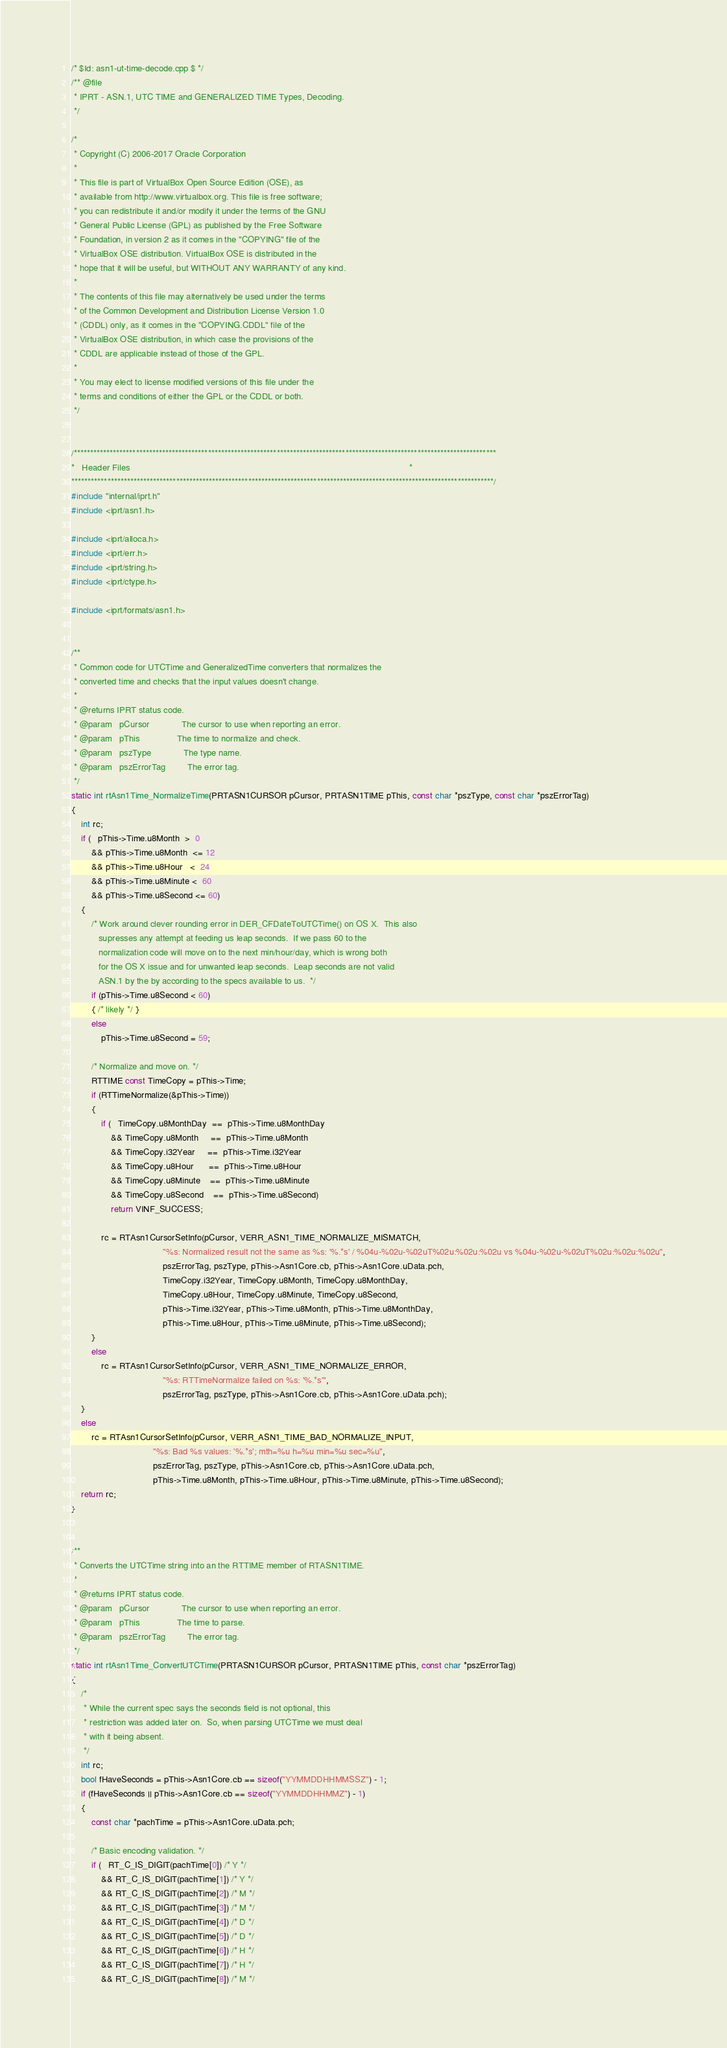Convert code to text. <code><loc_0><loc_0><loc_500><loc_500><_C++_>/* $Id: asn1-ut-time-decode.cpp $ */
/** @file
 * IPRT - ASN.1, UTC TIME and GENERALIZED TIME Types, Decoding.
 */

/*
 * Copyright (C) 2006-2017 Oracle Corporation
 *
 * This file is part of VirtualBox Open Source Edition (OSE), as
 * available from http://www.virtualbox.org. This file is free software;
 * you can redistribute it and/or modify it under the terms of the GNU
 * General Public License (GPL) as published by the Free Software
 * Foundation, in version 2 as it comes in the "COPYING" file of the
 * VirtualBox OSE distribution. VirtualBox OSE is distributed in the
 * hope that it will be useful, but WITHOUT ANY WARRANTY of any kind.
 *
 * The contents of this file may alternatively be used under the terms
 * of the Common Development and Distribution License Version 1.0
 * (CDDL) only, as it comes in the "COPYING.CDDL" file of the
 * VirtualBox OSE distribution, in which case the provisions of the
 * CDDL are applicable instead of those of the GPL.
 *
 * You may elect to license modified versions of this file under the
 * terms and conditions of either the GPL or the CDDL or both.
 */


/*********************************************************************************************************************************
*   Header Files                                                                                                                 *
*********************************************************************************************************************************/
#include "internal/iprt.h"
#include <iprt/asn1.h>

#include <iprt/alloca.h>
#include <iprt/err.h>
#include <iprt/string.h>
#include <iprt/ctype.h>

#include <iprt/formats/asn1.h>


/**
 * Common code for UTCTime and GeneralizedTime converters that normalizes the
 * converted time and checks that the input values doesn't change.
 *
 * @returns IPRT status code.
 * @param   pCursor             The cursor to use when reporting an error.
 * @param   pThis               The time to normalize and check.
 * @param   pszType             The type name.
 * @param   pszErrorTag         The error tag.
 */
static int rtAsn1Time_NormalizeTime(PRTASN1CURSOR pCursor, PRTASN1TIME pThis, const char *pszType, const char *pszErrorTag)
{
    int rc;
    if (   pThis->Time.u8Month  >  0
        && pThis->Time.u8Month  <= 12
        && pThis->Time.u8Hour   <  24
        && pThis->Time.u8Minute <  60
        && pThis->Time.u8Second <= 60)
    {
        /* Work around clever rounding error in DER_CFDateToUTCTime() on OS X.  This also
           supresses any attempt at feeding us leap seconds.  If we pass 60 to the
           normalization code will move on to the next min/hour/day, which is wrong both
           for the OS X issue and for unwanted leap seconds.  Leap seconds are not valid
           ASN.1 by the by according to the specs available to us.  */
        if (pThis->Time.u8Second < 60)
        { /* likely */ }
        else
            pThis->Time.u8Second = 59;

        /* Normalize and move on. */
        RTTIME const TimeCopy = pThis->Time;
        if (RTTimeNormalize(&pThis->Time))
        {
            if (   TimeCopy.u8MonthDay  ==  pThis->Time.u8MonthDay
                && TimeCopy.u8Month     ==  pThis->Time.u8Month
                && TimeCopy.i32Year     ==  pThis->Time.i32Year
                && TimeCopy.u8Hour      ==  pThis->Time.u8Hour
                && TimeCopy.u8Minute    ==  pThis->Time.u8Minute
                && TimeCopy.u8Second    ==  pThis->Time.u8Second)
                return VINF_SUCCESS;

            rc = RTAsn1CursorSetInfo(pCursor, VERR_ASN1_TIME_NORMALIZE_MISMATCH,
                                     "%s: Normalized result not the same as %s: '%.*s' / %04u-%02u-%02uT%02u:%02u:%02u vs %04u-%02u-%02uT%02u:%02u:%02u",
                                     pszErrorTag, pszType, pThis->Asn1Core.cb, pThis->Asn1Core.uData.pch,
                                     TimeCopy.i32Year, TimeCopy.u8Month, TimeCopy.u8MonthDay,
                                     TimeCopy.u8Hour, TimeCopy.u8Minute, TimeCopy.u8Second,
                                     pThis->Time.i32Year, pThis->Time.u8Month, pThis->Time.u8MonthDay,
                                     pThis->Time.u8Hour, pThis->Time.u8Minute, pThis->Time.u8Second);
        }
        else
            rc = RTAsn1CursorSetInfo(pCursor, VERR_ASN1_TIME_NORMALIZE_ERROR,
                                     "%s: RTTimeNormalize failed on %s: '%.*s'",
                                     pszErrorTag, pszType, pThis->Asn1Core.cb, pThis->Asn1Core.uData.pch);
    }
    else
        rc = RTAsn1CursorSetInfo(pCursor, VERR_ASN1_TIME_BAD_NORMALIZE_INPUT,
                                 "%s: Bad %s values: '%.*s'; mth=%u h=%u min=%u sec=%u",
                                 pszErrorTag, pszType, pThis->Asn1Core.cb, pThis->Asn1Core.uData.pch,
                                 pThis->Time.u8Month, pThis->Time.u8Hour, pThis->Time.u8Minute, pThis->Time.u8Second);
    return rc;
}


/**
 * Converts the UTCTime string into an the RTTIME member of RTASN1TIME.
 *
 * @returns IPRT status code.
 * @param   pCursor             The cursor to use when reporting an error.
 * @param   pThis               The time to parse.
 * @param   pszErrorTag         The error tag.
 */
static int rtAsn1Time_ConvertUTCTime(PRTASN1CURSOR pCursor, PRTASN1TIME pThis, const char *pszErrorTag)
{
    /*
     * While the current spec says the seconds field is not optional, this
     * restriction was added later on.  So, when parsing UTCTime we must deal
     * with it being absent.
     */
    int rc;
    bool fHaveSeconds = pThis->Asn1Core.cb == sizeof("YYMMDDHHMMSSZ") - 1;
    if (fHaveSeconds || pThis->Asn1Core.cb == sizeof("YYMMDDHHMMZ") - 1)
    {
        const char *pachTime = pThis->Asn1Core.uData.pch;

        /* Basic encoding validation. */
        if (   RT_C_IS_DIGIT(pachTime[0]) /* Y */
            && RT_C_IS_DIGIT(pachTime[1]) /* Y */
            && RT_C_IS_DIGIT(pachTime[2]) /* M */
            && RT_C_IS_DIGIT(pachTime[3]) /* M */
            && RT_C_IS_DIGIT(pachTime[4]) /* D */
            && RT_C_IS_DIGIT(pachTime[5]) /* D */
            && RT_C_IS_DIGIT(pachTime[6]) /* H */
            && RT_C_IS_DIGIT(pachTime[7]) /* H */
            && RT_C_IS_DIGIT(pachTime[8]) /* M */</code> 